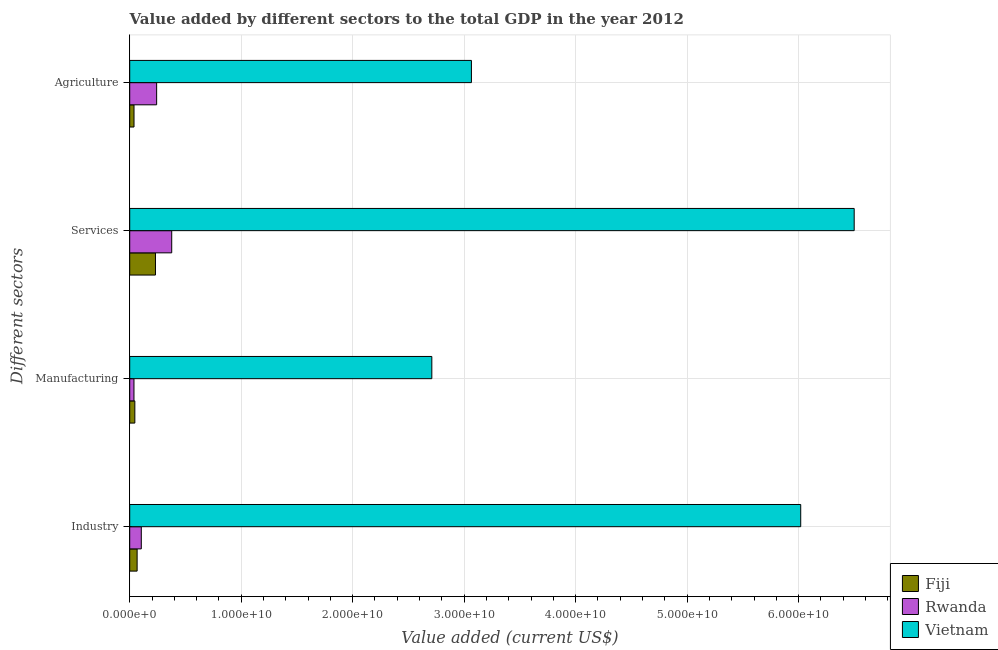How many different coloured bars are there?
Give a very brief answer. 3. How many groups of bars are there?
Provide a short and direct response. 4. How many bars are there on the 3rd tick from the top?
Keep it short and to the point. 3. How many bars are there on the 1st tick from the bottom?
Your answer should be compact. 3. What is the label of the 1st group of bars from the top?
Offer a terse response. Agriculture. What is the value added by services sector in Rwanda?
Offer a terse response. 3.77e+09. Across all countries, what is the maximum value added by industrial sector?
Give a very brief answer. 6.02e+1. Across all countries, what is the minimum value added by industrial sector?
Ensure brevity in your answer.  6.64e+08. In which country was the value added by agricultural sector maximum?
Provide a short and direct response. Vietnam. In which country was the value added by agricultural sector minimum?
Your response must be concise. Fiji. What is the total value added by agricultural sector in the graph?
Make the answer very short. 3.34e+1. What is the difference between the value added by services sector in Vietnam and that in Rwanda?
Keep it short and to the point. 6.12e+1. What is the difference between the value added by manufacturing sector in Rwanda and the value added by industrial sector in Fiji?
Your answer should be compact. -2.83e+08. What is the average value added by agricultural sector per country?
Offer a terse response. 1.11e+1. What is the difference between the value added by agricultural sector and value added by manufacturing sector in Vietnam?
Provide a succinct answer. 3.55e+09. What is the ratio of the value added by industrial sector in Vietnam to that in Rwanda?
Keep it short and to the point. 57.95. Is the value added by services sector in Fiji less than that in Rwanda?
Provide a short and direct response. Yes. What is the difference between the highest and the second highest value added by agricultural sector?
Your answer should be compact. 2.82e+1. What is the difference between the highest and the lowest value added by manufacturing sector?
Provide a succinct answer. 2.67e+1. Is it the case that in every country, the sum of the value added by industrial sector and value added by manufacturing sector is greater than the sum of value added by services sector and value added by agricultural sector?
Ensure brevity in your answer.  No. What does the 1st bar from the top in Manufacturing represents?
Provide a short and direct response. Vietnam. What does the 1st bar from the bottom in Manufacturing represents?
Ensure brevity in your answer.  Fiji. Is it the case that in every country, the sum of the value added by industrial sector and value added by manufacturing sector is greater than the value added by services sector?
Your answer should be compact. No. How many bars are there?
Your response must be concise. 12. Are all the bars in the graph horizontal?
Keep it short and to the point. Yes. How many countries are there in the graph?
Your answer should be very brief. 3. What is the difference between two consecutive major ticks on the X-axis?
Provide a short and direct response. 1.00e+1. Does the graph contain any zero values?
Give a very brief answer. No. How many legend labels are there?
Provide a short and direct response. 3. What is the title of the graph?
Provide a succinct answer. Value added by different sectors to the total GDP in the year 2012. Does "OECD members" appear as one of the legend labels in the graph?
Your response must be concise. No. What is the label or title of the X-axis?
Provide a succinct answer. Value added (current US$). What is the label or title of the Y-axis?
Ensure brevity in your answer.  Different sectors. What is the Value added (current US$) in Fiji in Industry?
Your answer should be compact. 6.64e+08. What is the Value added (current US$) in Rwanda in Industry?
Your answer should be very brief. 1.04e+09. What is the Value added (current US$) of Vietnam in Industry?
Your answer should be compact. 6.02e+1. What is the Value added (current US$) in Fiji in Manufacturing?
Provide a short and direct response. 4.59e+08. What is the Value added (current US$) of Rwanda in Manufacturing?
Offer a terse response. 3.81e+08. What is the Value added (current US$) of Vietnam in Manufacturing?
Provide a succinct answer. 2.71e+1. What is the Value added (current US$) of Fiji in Services?
Your answer should be compact. 2.31e+09. What is the Value added (current US$) of Rwanda in Services?
Offer a very short reply. 3.77e+09. What is the Value added (current US$) in Vietnam in Services?
Offer a very short reply. 6.50e+1. What is the Value added (current US$) of Fiji in Agriculture?
Your answer should be compact. 3.84e+08. What is the Value added (current US$) in Rwanda in Agriculture?
Provide a short and direct response. 2.41e+09. What is the Value added (current US$) in Vietnam in Agriculture?
Provide a short and direct response. 3.06e+1. Across all Different sectors, what is the maximum Value added (current US$) of Fiji?
Give a very brief answer. 2.31e+09. Across all Different sectors, what is the maximum Value added (current US$) in Rwanda?
Provide a short and direct response. 3.77e+09. Across all Different sectors, what is the maximum Value added (current US$) in Vietnam?
Keep it short and to the point. 6.50e+1. Across all Different sectors, what is the minimum Value added (current US$) in Fiji?
Offer a terse response. 3.84e+08. Across all Different sectors, what is the minimum Value added (current US$) of Rwanda?
Give a very brief answer. 3.81e+08. Across all Different sectors, what is the minimum Value added (current US$) in Vietnam?
Your answer should be compact. 2.71e+1. What is the total Value added (current US$) in Fiji in the graph?
Your response must be concise. 3.82e+09. What is the total Value added (current US$) of Rwanda in the graph?
Your answer should be compact. 7.60e+09. What is the total Value added (current US$) of Vietnam in the graph?
Offer a terse response. 1.83e+11. What is the difference between the Value added (current US$) of Fiji in Industry and that in Manufacturing?
Your answer should be compact. 2.05e+08. What is the difference between the Value added (current US$) of Rwanda in Industry and that in Manufacturing?
Provide a short and direct response. 6.58e+08. What is the difference between the Value added (current US$) of Vietnam in Industry and that in Manufacturing?
Make the answer very short. 3.31e+1. What is the difference between the Value added (current US$) of Fiji in Industry and that in Services?
Make the answer very short. -1.65e+09. What is the difference between the Value added (current US$) of Rwanda in Industry and that in Services?
Make the answer very short. -2.73e+09. What is the difference between the Value added (current US$) in Vietnam in Industry and that in Services?
Your response must be concise. -4.80e+09. What is the difference between the Value added (current US$) in Fiji in Industry and that in Agriculture?
Keep it short and to the point. 2.80e+08. What is the difference between the Value added (current US$) of Rwanda in Industry and that in Agriculture?
Give a very brief answer. -1.38e+09. What is the difference between the Value added (current US$) in Vietnam in Industry and that in Agriculture?
Keep it short and to the point. 2.95e+1. What is the difference between the Value added (current US$) in Fiji in Manufacturing and that in Services?
Provide a short and direct response. -1.85e+09. What is the difference between the Value added (current US$) in Rwanda in Manufacturing and that in Services?
Your answer should be very brief. -3.39e+09. What is the difference between the Value added (current US$) in Vietnam in Manufacturing and that in Services?
Your answer should be very brief. -3.79e+1. What is the difference between the Value added (current US$) of Fiji in Manufacturing and that in Agriculture?
Keep it short and to the point. 7.49e+07. What is the difference between the Value added (current US$) in Rwanda in Manufacturing and that in Agriculture?
Provide a succinct answer. -2.03e+09. What is the difference between the Value added (current US$) in Vietnam in Manufacturing and that in Agriculture?
Your answer should be compact. -3.55e+09. What is the difference between the Value added (current US$) in Fiji in Services and that in Agriculture?
Offer a terse response. 1.92e+09. What is the difference between the Value added (current US$) in Rwanda in Services and that in Agriculture?
Ensure brevity in your answer.  1.35e+09. What is the difference between the Value added (current US$) in Vietnam in Services and that in Agriculture?
Make the answer very short. 3.43e+1. What is the difference between the Value added (current US$) of Fiji in Industry and the Value added (current US$) of Rwanda in Manufacturing?
Provide a succinct answer. 2.83e+08. What is the difference between the Value added (current US$) in Fiji in Industry and the Value added (current US$) in Vietnam in Manufacturing?
Your response must be concise. -2.64e+1. What is the difference between the Value added (current US$) of Rwanda in Industry and the Value added (current US$) of Vietnam in Manufacturing?
Your response must be concise. -2.61e+1. What is the difference between the Value added (current US$) in Fiji in Industry and the Value added (current US$) in Rwanda in Services?
Offer a terse response. -3.10e+09. What is the difference between the Value added (current US$) of Fiji in Industry and the Value added (current US$) of Vietnam in Services?
Offer a very short reply. -6.43e+1. What is the difference between the Value added (current US$) in Rwanda in Industry and the Value added (current US$) in Vietnam in Services?
Keep it short and to the point. -6.39e+1. What is the difference between the Value added (current US$) in Fiji in Industry and the Value added (current US$) in Rwanda in Agriculture?
Offer a very short reply. -1.75e+09. What is the difference between the Value added (current US$) in Fiji in Industry and the Value added (current US$) in Vietnam in Agriculture?
Your response must be concise. -3.00e+1. What is the difference between the Value added (current US$) in Rwanda in Industry and the Value added (current US$) in Vietnam in Agriculture?
Provide a short and direct response. -2.96e+1. What is the difference between the Value added (current US$) of Fiji in Manufacturing and the Value added (current US$) of Rwanda in Services?
Provide a succinct answer. -3.31e+09. What is the difference between the Value added (current US$) in Fiji in Manufacturing and the Value added (current US$) in Vietnam in Services?
Provide a succinct answer. -6.45e+1. What is the difference between the Value added (current US$) of Rwanda in Manufacturing and the Value added (current US$) of Vietnam in Services?
Your answer should be compact. -6.46e+1. What is the difference between the Value added (current US$) of Fiji in Manufacturing and the Value added (current US$) of Rwanda in Agriculture?
Your answer should be compact. -1.95e+09. What is the difference between the Value added (current US$) in Fiji in Manufacturing and the Value added (current US$) in Vietnam in Agriculture?
Give a very brief answer. -3.02e+1. What is the difference between the Value added (current US$) in Rwanda in Manufacturing and the Value added (current US$) in Vietnam in Agriculture?
Your answer should be very brief. -3.03e+1. What is the difference between the Value added (current US$) of Fiji in Services and the Value added (current US$) of Rwanda in Agriculture?
Make the answer very short. -1.05e+08. What is the difference between the Value added (current US$) in Fiji in Services and the Value added (current US$) in Vietnam in Agriculture?
Keep it short and to the point. -2.83e+1. What is the difference between the Value added (current US$) in Rwanda in Services and the Value added (current US$) in Vietnam in Agriculture?
Your answer should be compact. -2.69e+1. What is the average Value added (current US$) in Fiji per Different sectors?
Keep it short and to the point. 9.54e+08. What is the average Value added (current US$) of Rwanda per Different sectors?
Give a very brief answer. 1.90e+09. What is the average Value added (current US$) in Vietnam per Different sectors?
Keep it short and to the point. 4.57e+1. What is the difference between the Value added (current US$) of Fiji and Value added (current US$) of Rwanda in Industry?
Your answer should be compact. -3.74e+08. What is the difference between the Value added (current US$) in Fiji and Value added (current US$) in Vietnam in Industry?
Make the answer very short. -5.95e+1. What is the difference between the Value added (current US$) of Rwanda and Value added (current US$) of Vietnam in Industry?
Make the answer very short. -5.91e+1. What is the difference between the Value added (current US$) in Fiji and Value added (current US$) in Rwanda in Manufacturing?
Provide a succinct answer. 7.83e+07. What is the difference between the Value added (current US$) in Fiji and Value added (current US$) in Vietnam in Manufacturing?
Give a very brief answer. -2.66e+1. What is the difference between the Value added (current US$) of Rwanda and Value added (current US$) of Vietnam in Manufacturing?
Provide a succinct answer. -2.67e+1. What is the difference between the Value added (current US$) in Fiji and Value added (current US$) in Rwanda in Services?
Provide a succinct answer. -1.46e+09. What is the difference between the Value added (current US$) in Fiji and Value added (current US$) in Vietnam in Services?
Ensure brevity in your answer.  -6.27e+1. What is the difference between the Value added (current US$) of Rwanda and Value added (current US$) of Vietnam in Services?
Your answer should be very brief. -6.12e+1. What is the difference between the Value added (current US$) in Fiji and Value added (current US$) in Rwanda in Agriculture?
Your answer should be compact. -2.03e+09. What is the difference between the Value added (current US$) of Fiji and Value added (current US$) of Vietnam in Agriculture?
Keep it short and to the point. -3.03e+1. What is the difference between the Value added (current US$) in Rwanda and Value added (current US$) in Vietnam in Agriculture?
Provide a succinct answer. -2.82e+1. What is the ratio of the Value added (current US$) of Fiji in Industry to that in Manufacturing?
Your answer should be very brief. 1.45. What is the ratio of the Value added (current US$) in Rwanda in Industry to that in Manufacturing?
Keep it short and to the point. 2.73. What is the ratio of the Value added (current US$) in Vietnam in Industry to that in Manufacturing?
Offer a very short reply. 2.22. What is the ratio of the Value added (current US$) in Fiji in Industry to that in Services?
Your response must be concise. 0.29. What is the ratio of the Value added (current US$) of Rwanda in Industry to that in Services?
Keep it short and to the point. 0.28. What is the ratio of the Value added (current US$) of Vietnam in Industry to that in Services?
Ensure brevity in your answer.  0.93. What is the ratio of the Value added (current US$) of Fiji in Industry to that in Agriculture?
Provide a succinct answer. 1.73. What is the ratio of the Value added (current US$) of Rwanda in Industry to that in Agriculture?
Your response must be concise. 0.43. What is the ratio of the Value added (current US$) of Vietnam in Industry to that in Agriculture?
Provide a short and direct response. 1.96. What is the ratio of the Value added (current US$) of Fiji in Manufacturing to that in Services?
Ensure brevity in your answer.  0.2. What is the ratio of the Value added (current US$) of Rwanda in Manufacturing to that in Services?
Offer a very short reply. 0.1. What is the ratio of the Value added (current US$) of Vietnam in Manufacturing to that in Services?
Keep it short and to the point. 0.42. What is the ratio of the Value added (current US$) of Fiji in Manufacturing to that in Agriculture?
Provide a short and direct response. 1.19. What is the ratio of the Value added (current US$) in Rwanda in Manufacturing to that in Agriculture?
Give a very brief answer. 0.16. What is the ratio of the Value added (current US$) in Vietnam in Manufacturing to that in Agriculture?
Your response must be concise. 0.88. What is the ratio of the Value added (current US$) in Fiji in Services to that in Agriculture?
Keep it short and to the point. 6.01. What is the ratio of the Value added (current US$) in Rwanda in Services to that in Agriculture?
Offer a terse response. 1.56. What is the ratio of the Value added (current US$) of Vietnam in Services to that in Agriculture?
Provide a short and direct response. 2.12. What is the difference between the highest and the second highest Value added (current US$) in Fiji?
Provide a succinct answer. 1.65e+09. What is the difference between the highest and the second highest Value added (current US$) of Rwanda?
Keep it short and to the point. 1.35e+09. What is the difference between the highest and the second highest Value added (current US$) in Vietnam?
Provide a succinct answer. 4.80e+09. What is the difference between the highest and the lowest Value added (current US$) in Fiji?
Offer a very short reply. 1.92e+09. What is the difference between the highest and the lowest Value added (current US$) in Rwanda?
Offer a terse response. 3.39e+09. What is the difference between the highest and the lowest Value added (current US$) in Vietnam?
Your answer should be compact. 3.79e+1. 